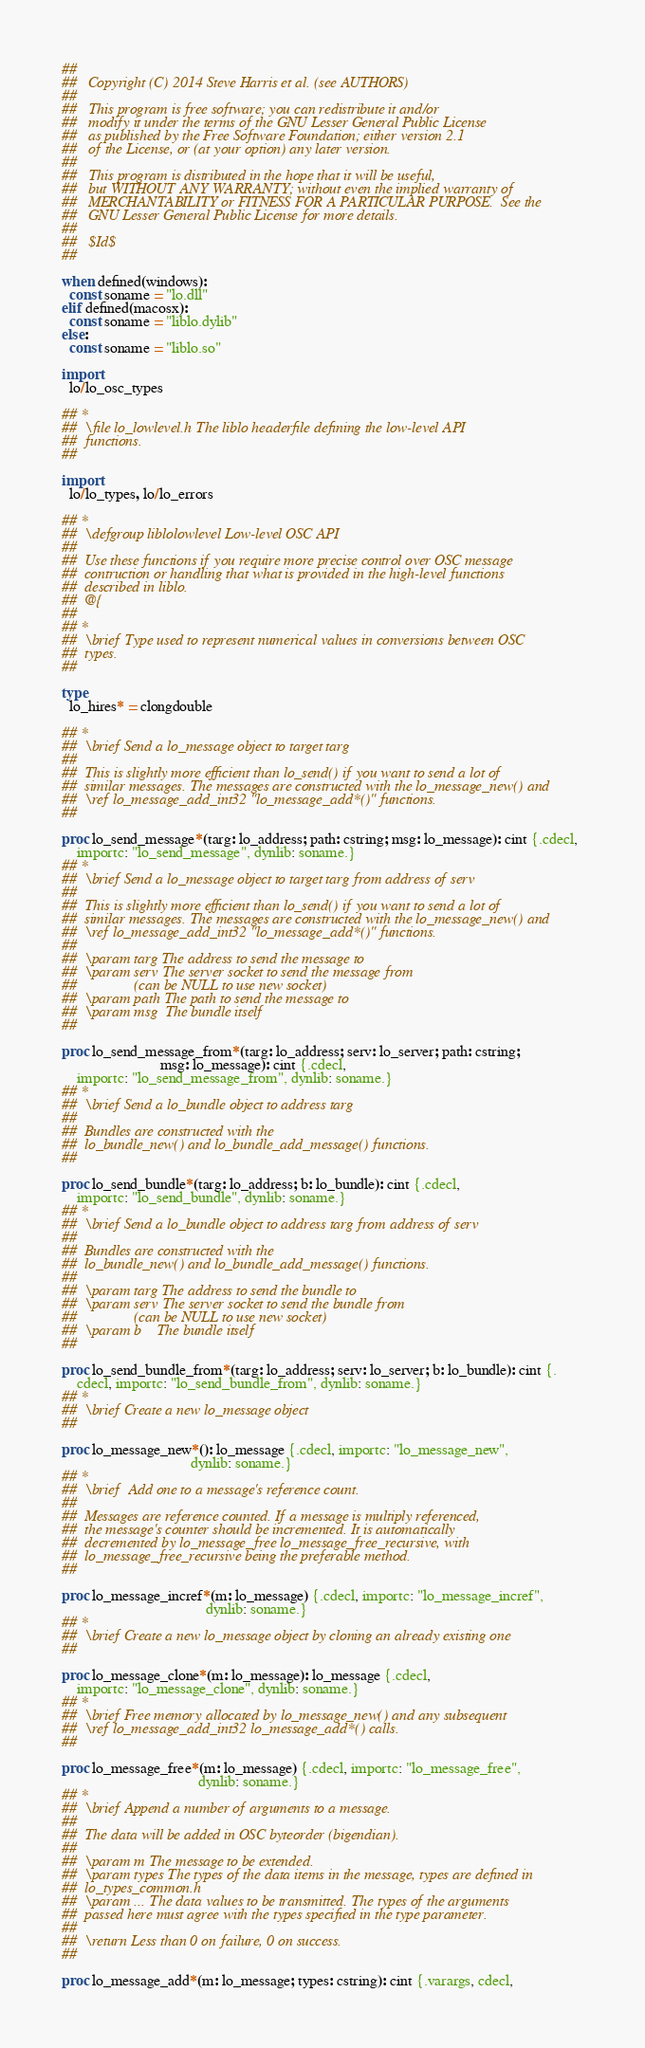<code> <loc_0><loc_0><loc_500><loc_500><_Nim_>## 
##   Copyright (C) 2014 Steve Harris et al. (see AUTHORS)
## 
##   This program is free software; you can redistribute it and/or
##   modify it under the terms of the GNU Lesser General Public License
##   as published by the Free Software Foundation; either version 2.1
##   of the License, or (at your option) any later version.
## 
##   This program is distributed in the hope that it will be useful,
##   but WITHOUT ANY WARRANTY; without even the implied warranty of
##   MERCHANTABILITY or FITNESS FOR A PARTICULAR PURPOSE.  See the
##   GNU Lesser General Public License for more details.
## 
##   $Id$
## 

when defined(windows):
  const soname = "lo.dll"
elif defined(macosx):
  const soname = "liblo.dylib"
else:
  const soname = "liblo.so"

import
  lo/lo_osc_types

## *
##  \file lo_lowlevel.h The liblo headerfile defining the low-level API
##  functions.
## 

import
  lo/lo_types, lo/lo_errors

## *
##  \defgroup liblolowlevel Low-level OSC API
## 
##  Use these functions if you require more precise control over OSC message
##  contruction or handling that what is provided in the high-level functions
##  described in liblo.
##  @{
## 
## *
##  \brief Type used to represent numerical values in conversions between OSC
##  types.
## 

type
  lo_hires* = clongdouble

## *
##  \brief Send a lo_message object to target targ
## 
##  This is slightly more efficient than lo_send() if you want to send a lot of
##  similar messages. The messages are constructed with the lo_message_new() and
##  \ref lo_message_add_int32 "lo_message_add*()" functions.
## 

proc lo_send_message*(targ: lo_address; path: cstring; msg: lo_message): cint {.cdecl,
    importc: "lo_send_message", dynlib: soname.}
## *
##  \brief Send a lo_message object to target targ from address of serv
## 
##  This is slightly more efficient than lo_send() if you want to send a lot of
##  similar messages. The messages are constructed with the lo_message_new() and
##  \ref lo_message_add_int32 "lo_message_add*()" functions.
## 
##  \param targ The address to send the message to
##  \param serv The server socket to send the message from
##               (can be NULL to use new socket)
##  \param path The path to send the message to
##  \param msg  The bundle itself
## 

proc lo_send_message_from*(targ: lo_address; serv: lo_server; path: cstring;
                          msg: lo_message): cint {.cdecl,
    importc: "lo_send_message_from", dynlib: soname.}
## *
##  \brief Send a lo_bundle object to address targ
## 
##  Bundles are constructed with the
##  lo_bundle_new() and lo_bundle_add_message() functions.
## 

proc lo_send_bundle*(targ: lo_address; b: lo_bundle): cint {.cdecl,
    importc: "lo_send_bundle", dynlib: soname.}
## *
##  \brief Send a lo_bundle object to address targ from address of serv
## 
##  Bundles are constructed with the
##  lo_bundle_new() and lo_bundle_add_message() functions.
## 
##  \param targ The address to send the bundle to
##  \param serv The server socket to send the bundle from 
##               (can be NULL to use new socket)
##  \param b    The bundle itself
## 

proc lo_send_bundle_from*(targ: lo_address; serv: lo_server; b: lo_bundle): cint {.
    cdecl, importc: "lo_send_bundle_from", dynlib: soname.}
## *
##  \brief Create a new lo_message object
## 

proc lo_message_new*(): lo_message {.cdecl, importc: "lo_message_new",
                                  dynlib: soname.}
## *
##  \brief  Add one to a message's reference count.
## 
##  Messages are reference counted. If a message is multiply referenced,
##  the message's counter should be incremented. It is automatically
##  decremented by lo_message_free lo_message_free_recursive, with
##  lo_message_free_recursive being the preferable method.
## 

proc lo_message_incref*(m: lo_message) {.cdecl, importc: "lo_message_incref",
                                      dynlib: soname.}
## *
##  \brief Create a new lo_message object by cloning an already existing one
## 

proc lo_message_clone*(m: lo_message): lo_message {.cdecl,
    importc: "lo_message_clone", dynlib: soname.}
## *
##  \brief Free memory allocated by lo_message_new() and any subsequent
##  \ref lo_message_add_int32 lo_message_add*() calls.
## 

proc lo_message_free*(m: lo_message) {.cdecl, importc: "lo_message_free",
                                    dynlib: soname.}
## *
##  \brief Append a number of arguments to a message.
## 
##  The data will be added in OSC byteorder (bigendian).
## 
##  \param m The message to be extended.
##  \param types The types of the data items in the message, types are defined in
##  lo_types_common.h
##  \param ... The data values to be transmitted. The types of the arguments
##  passed here must agree with the types specified in the type parameter.
## 
##  \return Less than 0 on failure, 0 on success.
## 

proc lo_message_add*(m: lo_message; types: cstring): cint {.varargs, cdecl,</code> 